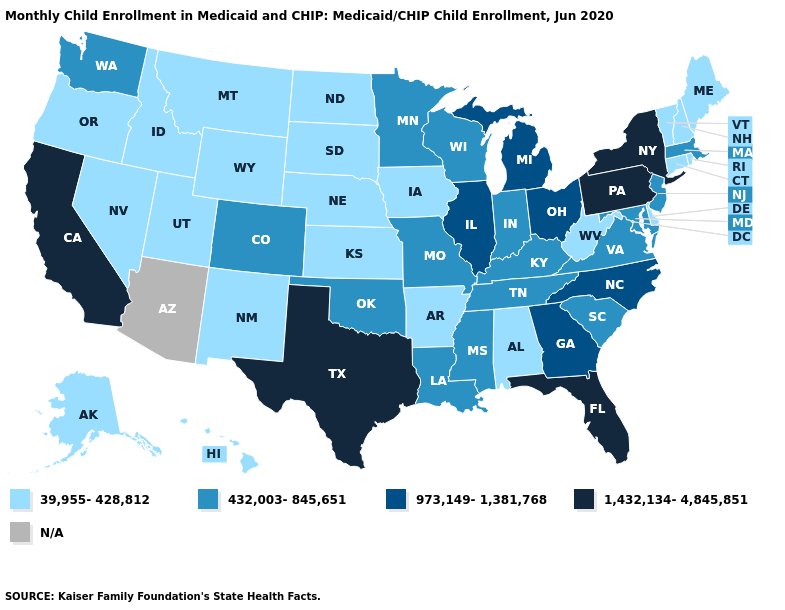What is the lowest value in the USA?
Short answer required. 39,955-428,812. Name the states that have a value in the range 39,955-428,812?
Be succinct. Alabama, Alaska, Arkansas, Connecticut, Delaware, Hawaii, Idaho, Iowa, Kansas, Maine, Montana, Nebraska, Nevada, New Hampshire, New Mexico, North Dakota, Oregon, Rhode Island, South Dakota, Utah, Vermont, West Virginia, Wyoming. Does the first symbol in the legend represent the smallest category?
Write a very short answer. Yes. Among the states that border Texas , which have the lowest value?
Short answer required. Arkansas, New Mexico. What is the value of Alabama?
Quick response, please. 39,955-428,812. Which states have the lowest value in the Northeast?
Quick response, please. Connecticut, Maine, New Hampshire, Rhode Island, Vermont. What is the value of California?
Write a very short answer. 1,432,134-4,845,851. What is the value of Wisconsin?
Give a very brief answer. 432,003-845,651. Name the states that have a value in the range 39,955-428,812?
Give a very brief answer. Alabama, Alaska, Arkansas, Connecticut, Delaware, Hawaii, Idaho, Iowa, Kansas, Maine, Montana, Nebraska, Nevada, New Hampshire, New Mexico, North Dakota, Oregon, Rhode Island, South Dakota, Utah, Vermont, West Virginia, Wyoming. What is the value of New Jersey?
Give a very brief answer. 432,003-845,651. Name the states that have a value in the range N/A?
Keep it brief. Arizona. Name the states that have a value in the range N/A?
Keep it brief. Arizona. Which states have the lowest value in the South?
Short answer required. Alabama, Arkansas, Delaware, West Virginia. Name the states that have a value in the range 39,955-428,812?
Give a very brief answer. Alabama, Alaska, Arkansas, Connecticut, Delaware, Hawaii, Idaho, Iowa, Kansas, Maine, Montana, Nebraska, Nevada, New Hampshire, New Mexico, North Dakota, Oregon, Rhode Island, South Dakota, Utah, Vermont, West Virginia, Wyoming. Is the legend a continuous bar?
Quick response, please. No. 